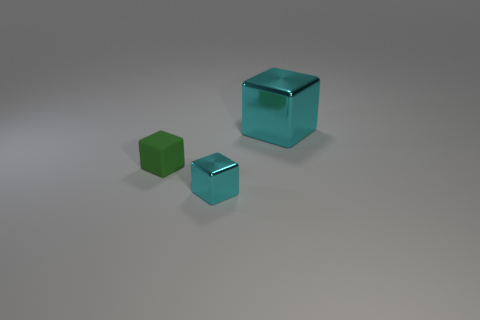There is a cube on the left side of the cyan thing that is in front of the matte block; how big is it?
Ensure brevity in your answer.  Small. What is the shape of the small cyan shiny thing?
Make the answer very short. Cube. What number of large things are purple blocks or cyan metallic cubes?
Give a very brief answer. 1. There is a green matte thing that is the same shape as the large cyan metal object; what size is it?
Your answer should be very brief. Small. How many cubes are both left of the large shiny object and to the right of the matte cube?
Provide a short and direct response. 1. Do the green object and the small object right of the green rubber thing have the same shape?
Ensure brevity in your answer.  Yes. Are there more tiny objects that are left of the tiny cyan metallic object than big brown shiny blocks?
Provide a succinct answer. Yes. Is the number of small cyan metallic blocks in front of the tiny cyan metallic cube less than the number of metallic cubes?
Keep it short and to the point. Yes. What number of small shiny cubes are the same color as the big cube?
Your response must be concise. 1. What is the object that is in front of the big thing and behind the small cyan metal cube made of?
Make the answer very short. Rubber. 